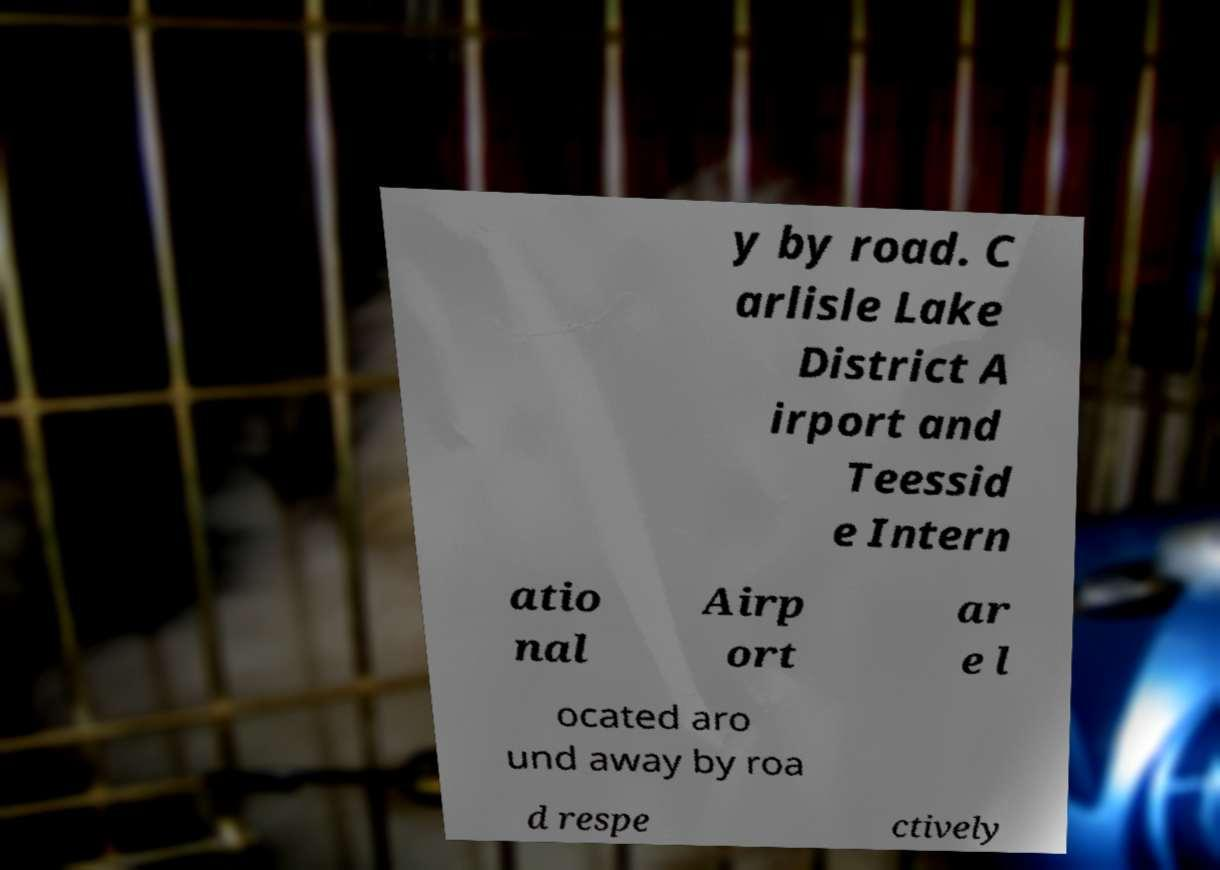Please read and relay the text visible in this image. What does it say? y by road. C arlisle Lake District A irport and Teessid e Intern atio nal Airp ort ar e l ocated aro und away by roa d respe ctively 